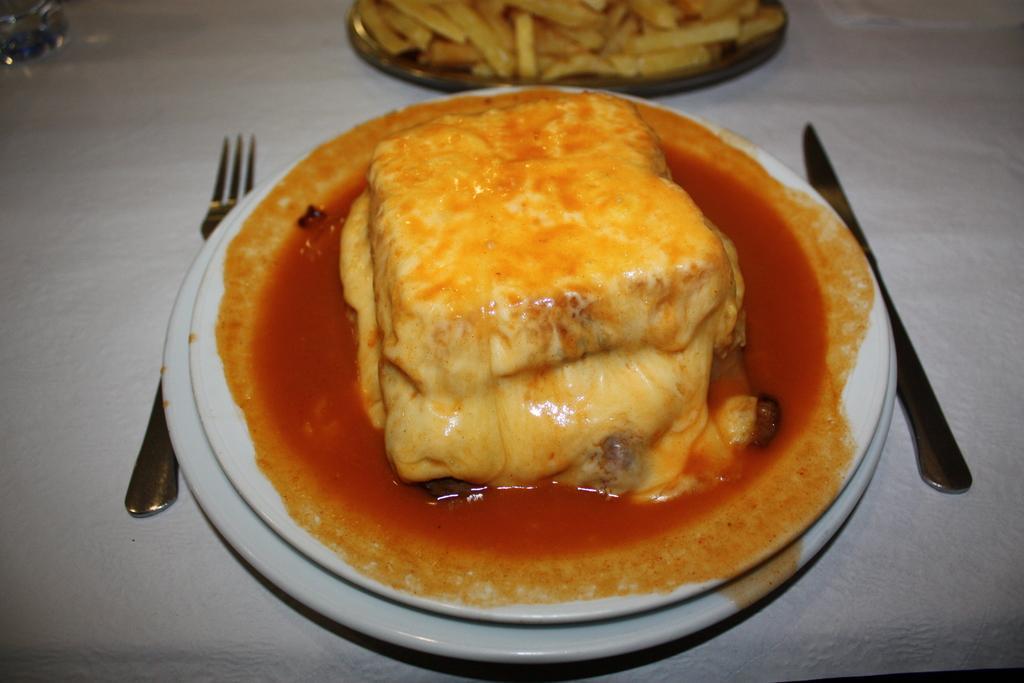Describe this image in one or two sentences. In this picture I can see there is some food placed on the plate and there is another plate of food placed on the backdrop. There is a fork and knife. 